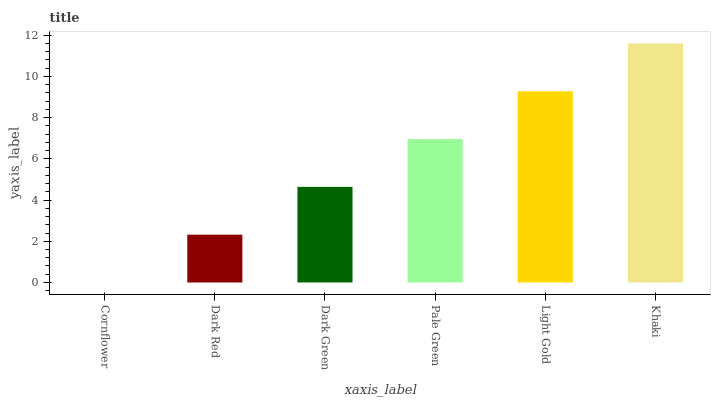Is Cornflower the minimum?
Answer yes or no. Yes. Is Khaki the maximum?
Answer yes or no. Yes. Is Dark Red the minimum?
Answer yes or no. No. Is Dark Red the maximum?
Answer yes or no. No. Is Dark Red greater than Cornflower?
Answer yes or no. Yes. Is Cornflower less than Dark Red?
Answer yes or no. Yes. Is Cornflower greater than Dark Red?
Answer yes or no. No. Is Dark Red less than Cornflower?
Answer yes or no. No. Is Pale Green the high median?
Answer yes or no. Yes. Is Dark Green the low median?
Answer yes or no. Yes. Is Dark Green the high median?
Answer yes or no. No. Is Cornflower the low median?
Answer yes or no. No. 